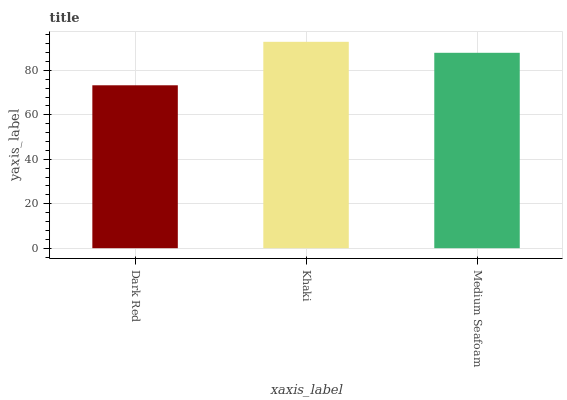Is Dark Red the minimum?
Answer yes or no. Yes. Is Khaki the maximum?
Answer yes or no. Yes. Is Medium Seafoam the minimum?
Answer yes or no. No. Is Medium Seafoam the maximum?
Answer yes or no. No. Is Khaki greater than Medium Seafoam?
Answer yes or no. Yes. Is Medium Seafoam less than Khaki?
Answer yes or no. Yes. Is Medium Seafoam greater than Khaki?
Answer yes or no. No. Is Khaki less than Medium Seafoam?
Answer yes or no. No. Is Medium Seafoam the high median?
Answer yes or no. Yes. Is Medium Seafoam the low median?
Answer yes or no. Yes. Is Khaki the high median?
Answer yes or no. No. Is Khaki the low median?
Answer yes or no. No. 